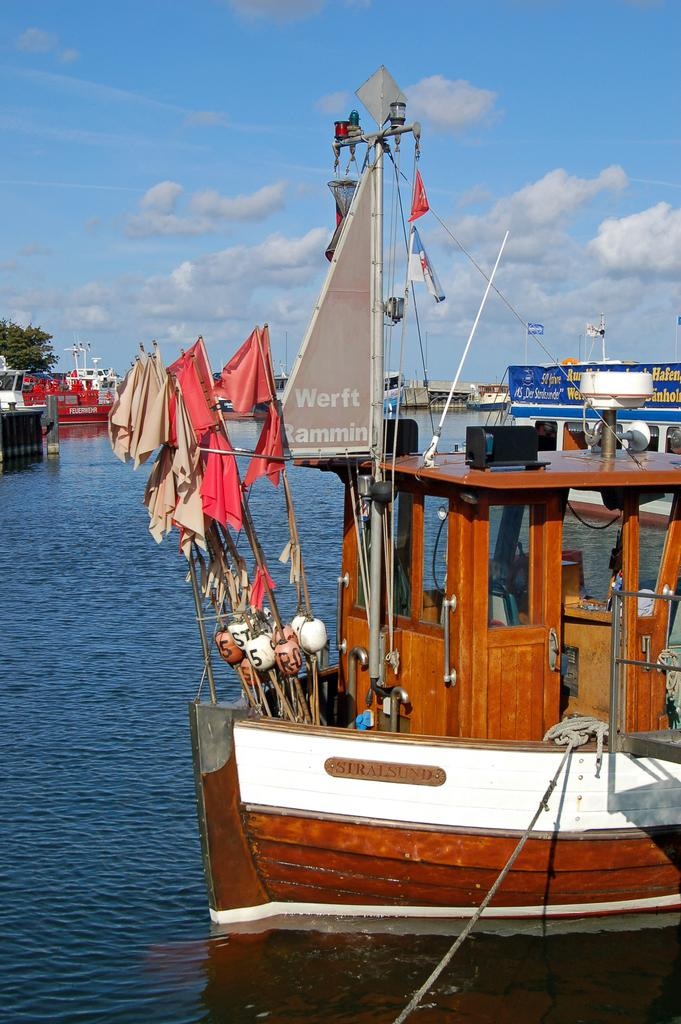What is on the water in the image? There are boats on the water in the image. What can be seen attached to the boats or other objects in the image? Flags are present in the image. What material is used to connect or secure objects in the image? Rope is visible in the image. What type of flat surface is present in the image? There is a board in the image. What type of vegetation is visible in the image? Trees are present in the image. What other objects can be seen in the image besides the boats, flags, rope, board, and trees? There are other objects in the image. What is visible in the background of the image? The sky with clouds is visible in the background of the image. Where is the gate located in the image? There is no gate present in the image. What type of animal is seen playing with a tub in the image? There is no animal or tub present in the image. 